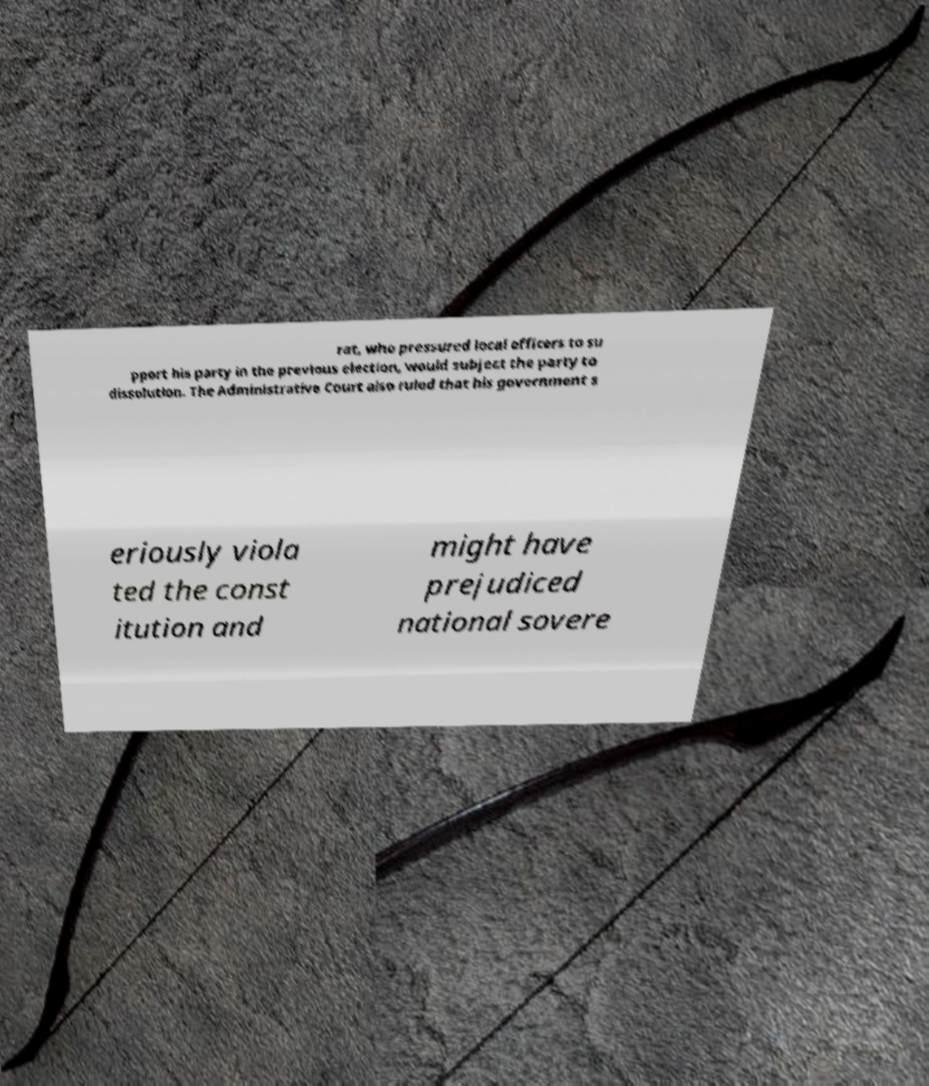Can you read and provide the text displayed in the image?This photo seems to have some interesting text. Can you extract and type it out for me? rat, who pressured local officers to su pport his party in the previous election, would subject the party to dissolution. The Administrative Court also ruled that his government s eriously viola ted the const itution and might have prejudiced national sovere 